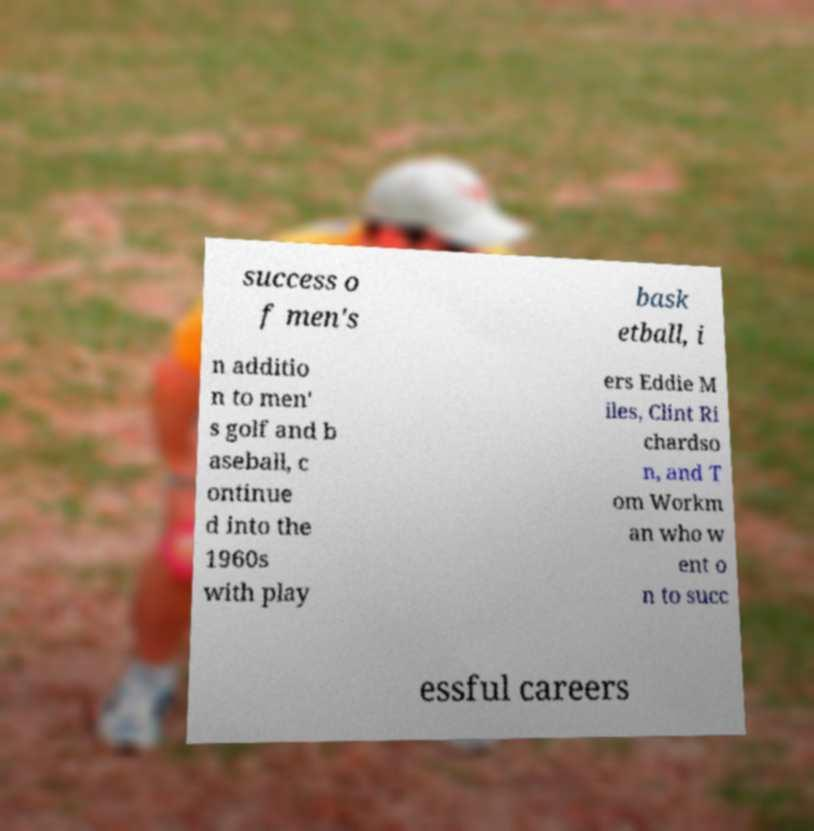Can you read and provide the text displayed in the image?This photo seems to have some interesting text. Can you extract and type it out for me? success o f men's bask etball, i n additio n to men' s golf and b aseball, c ontinue d into the 1960s with play ers Eddie M iles, Clint Ri chardso n, and T om Workm an who w ent o n to succ essful careers 